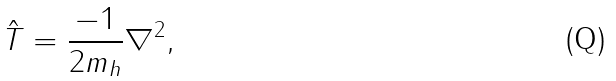Convert formula to latex. <formula><loc_0><loc_0><loc_500><loc_500>\hat { T } = \frac { - 1 } { 2 m _ { h } } \nabla ^ { 2 } ,</formula> 